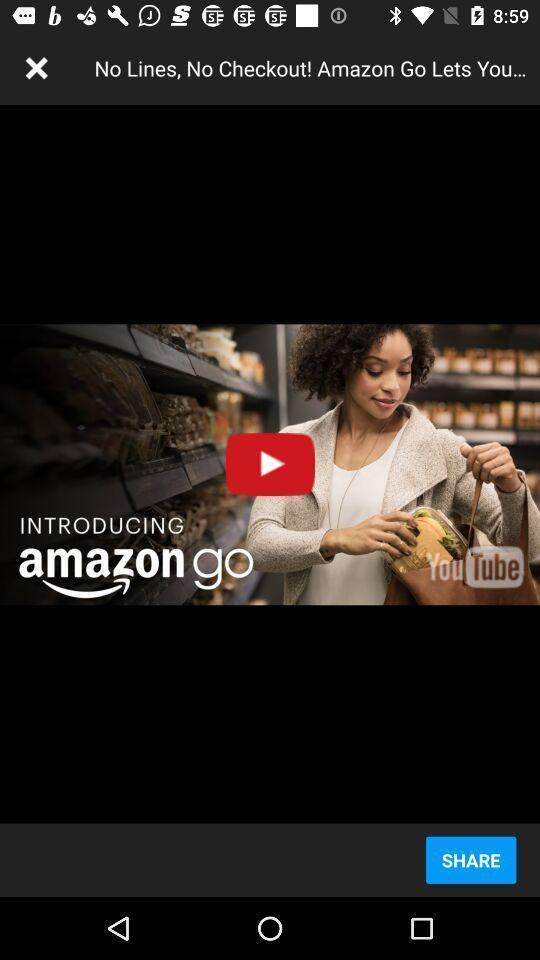What can you discern from this picture? Page showing a video to play on an app. 